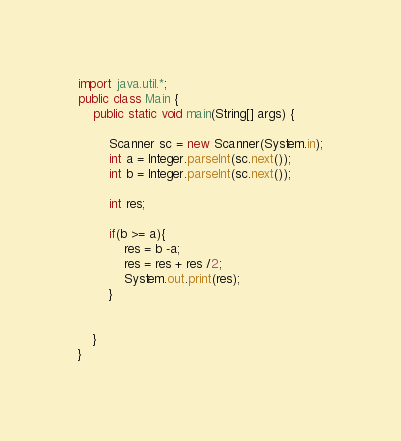<code> <loc_0><loc_0><loc_500><loc_500><_Java_>import java.util.*;
public class Main {
	public static void main(String[] args) {
	
		Scanner sc = new Scanner(System.in);
		int a = Integer.parseInt(sc.next());
		int b = Integer.parseInt(sc.next());

		int res;

		if(b >= a){
			res = b -a;
			res = res + res /2;
			System.out.print(res);
		}


	}
}</code> 